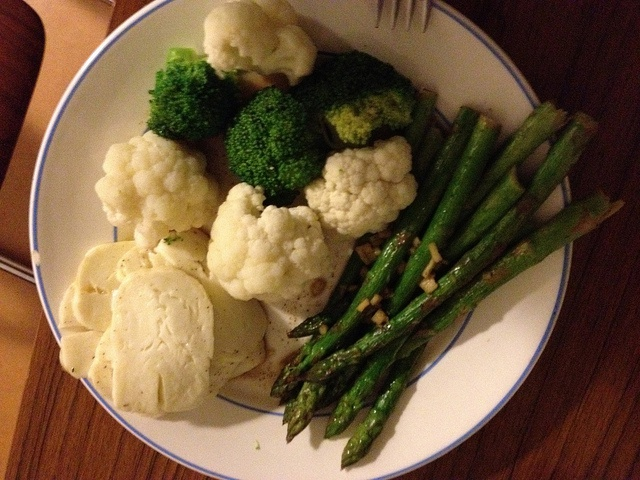Describe the objects in this image and their specific colors. I can see dining table in black, maroon, olive, and tan tones, broccoli in maroon, black, darkgreen, and tan tones, broccoli in maroon, black, olive, and darkgreen tones, broccoli in maroon, black, darkgreen, and olive tones, and chair in maroon, black, tan, and brown tones in this image. 